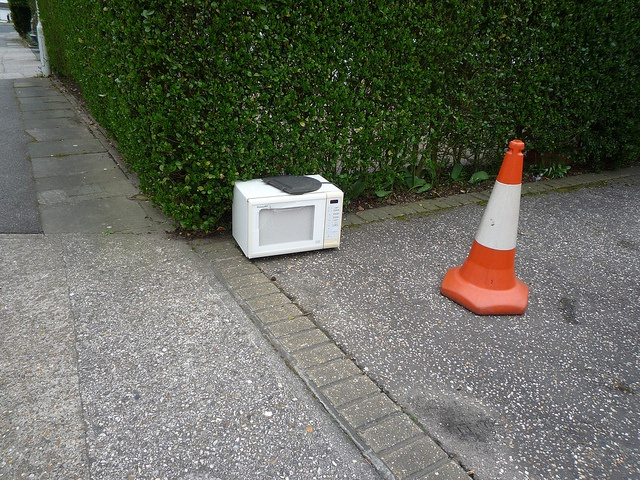Describe the objects in this image and their specific colors. I can see a microwave in lightgray, darkgray, gray, and black tones in this image. 